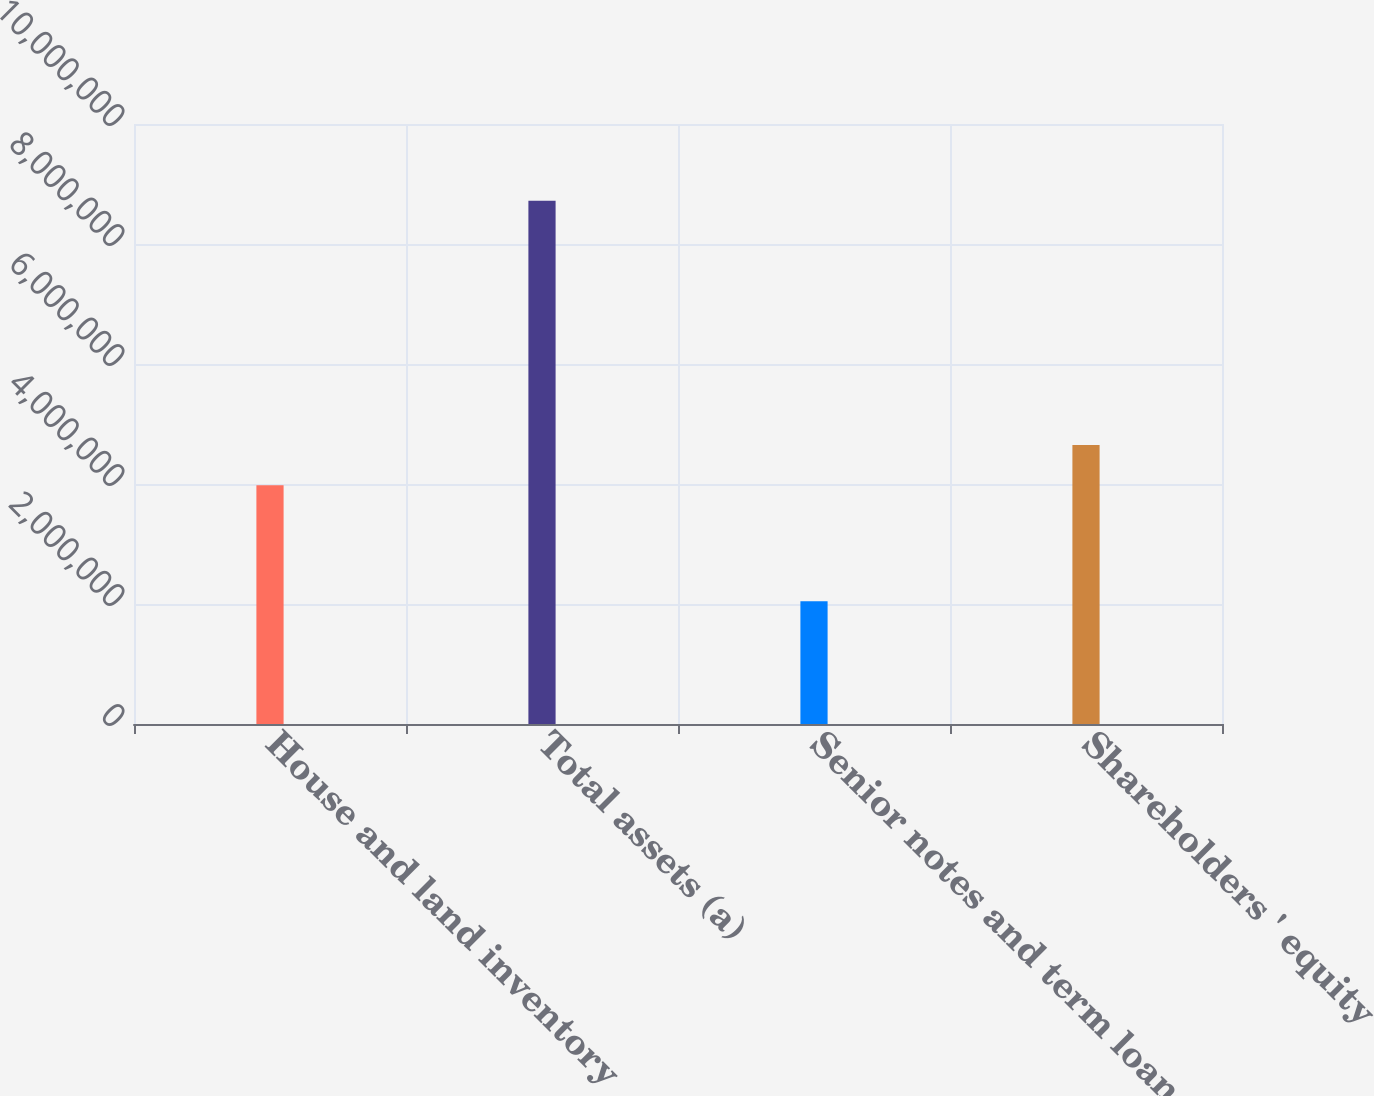Convert chart. <chart><loc_0><loc_0><loc_500><loc_500><bar_chart><fcel>House and land inventory<fcel>Total assets (a)<fcel>Senior notes and term loan (a)<fcel>Shareholders ' equity<nl><fcel>3.97856e+06<fcel>8.71989e+06<fcel>2.04391e+06<fcel>4.64895e+06<nl></chart> 